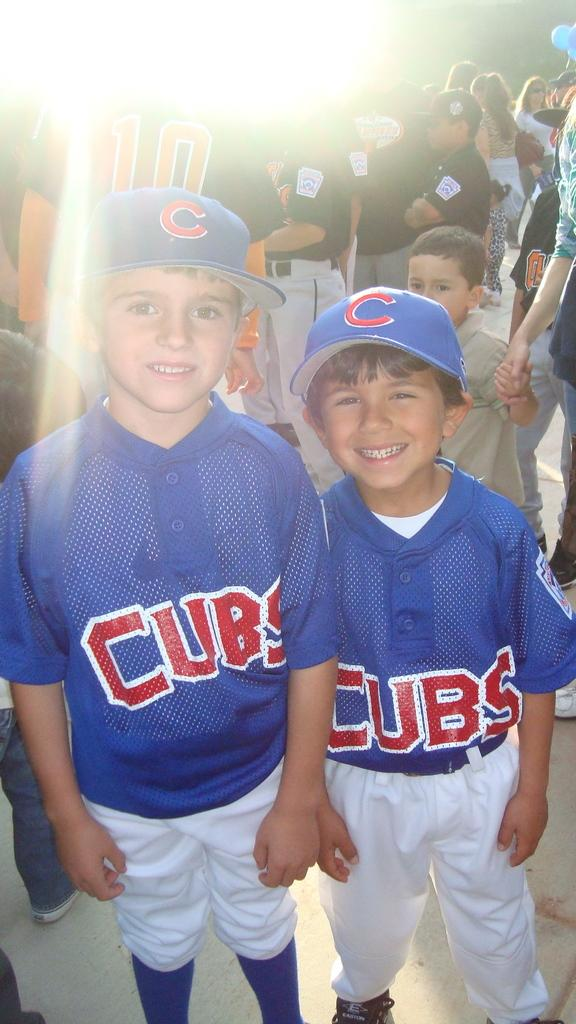Provide a one-sentence caption for the provided image. A couple of boys in Cubs baseball uniforms and wearing a C baseball cap. 